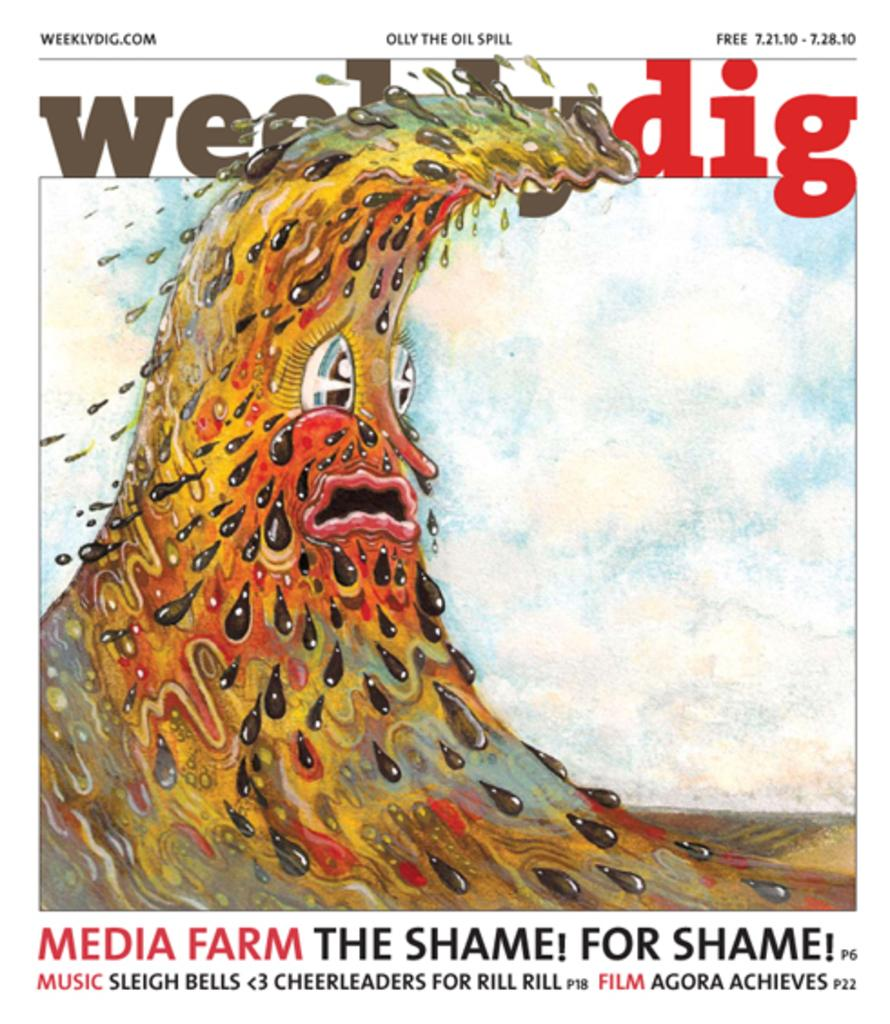<image>
Summarize the visual content of the image. A magazine cover of a really polluted source of water from the Weeklydig. 